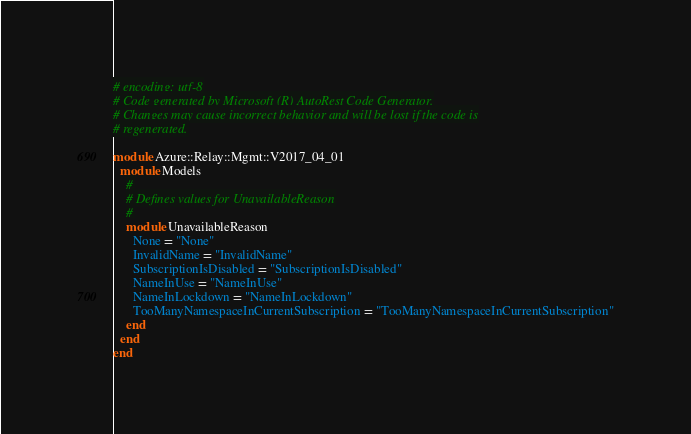<code> <loc_0><loc_0><loc_500><loc_500><_Ruby_># encoding: utf-8
# Code generated by Microsoft (R) AutoRest Code Generator.
# Changes may cause incorrect behavior and will be lost if the code is
# regenerated.

module Azure::Relay::Mgmt::V2017_04_01
  module Models
    #
    # Defines values for UnavailableReason
    #
    module UnavailableReason
      None = "None"
      InvalidName = "InvalidName"
      SubscriptionIsDisabled = "SubscriptionIsDisabled"
      NameInUse = "NameInUse"
      NameInLockdown = "NameInLockdown"
      TooManyNamespaceInCurrentSubscription = "TooManyNamespaceInCurrentSubscription"
    end
  end
end
</code> 